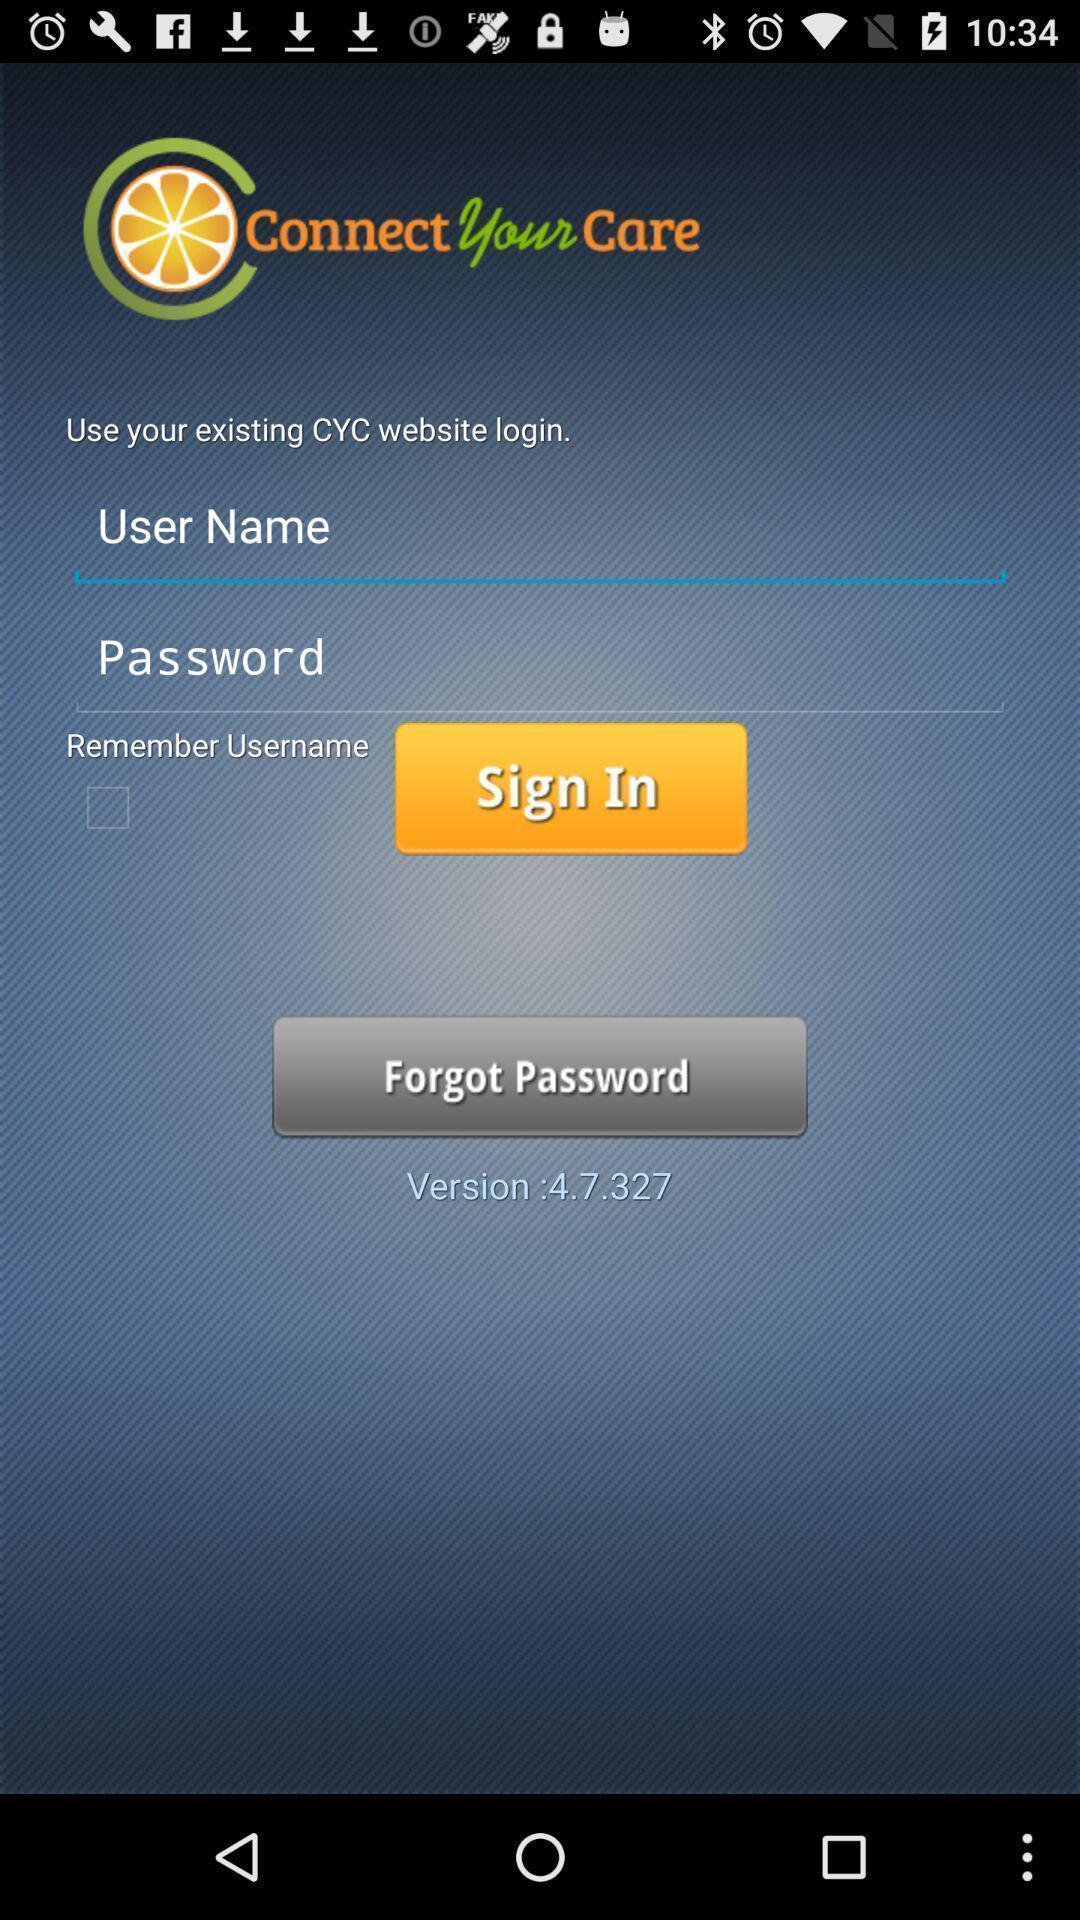Summarize the information in this screenshot. Sign in page. 